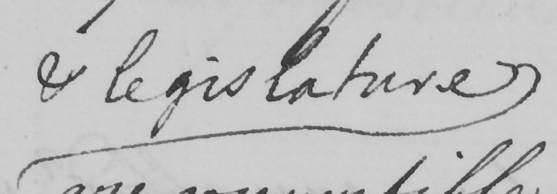Transcribe the text shown in this historical manuscript line. & legislature 